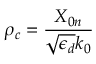Convert formula to latex. <formula><loc_0><loc_0><loc_500><loc_500>\rho _ { c } = \frac { X _ { 0 n } } { \sqrt { \epsilon _ { d } } k _ { 0 } }</formula> 